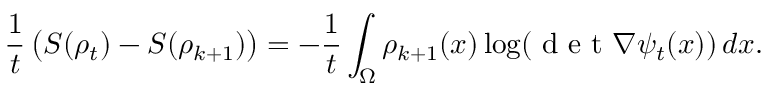Convert formula to latex. <formula><loc_0><loc_0><loc_500><loc_500>\frac { 1 } { t } \left ( S ( \rho _ { t } ) - S ( \rho _ { k + 1 } ) \right ) = - \frac { 1 } { t } \int _ { \Omega } \rho _ { k + 1 } ( x ) \log ( d e t \nabla \psi _ { t } ( x ) ) \, d x .</formula> 